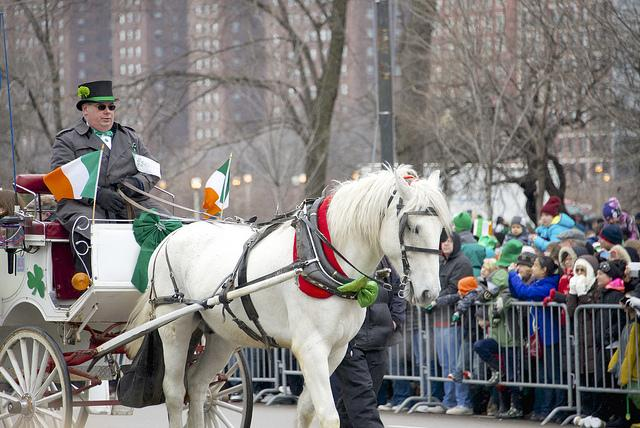What country's flag is on the white carriage? Please explain your reasoning. ireland. Green, white and orange are irish colors. 